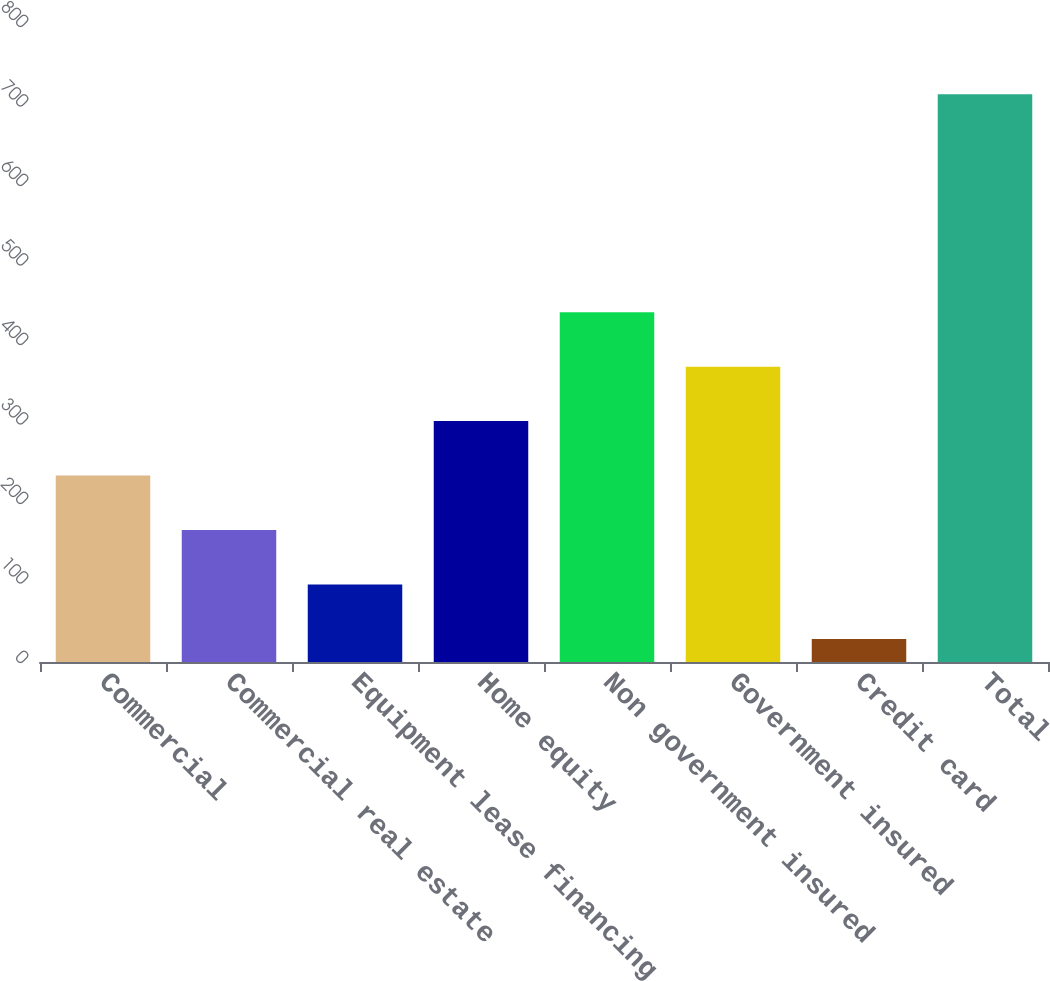Convert chart to OTSL. <chart><loc_0><loc_0><loc_500><loc_500><bar_chart><fcel>Commercial<fcel>Commercial real estate<fcel>Equipment lease financing<fcel>Home equity<fcel>Non government insured<fcel>Government insured<fcel>Credit card<fcel>Total<nl><fcel>234.5<fcel>166<fcel>97.5<fcel>303<fcel>440<fcel>371.5<fcel>29<fcel>714<nl></chart> 